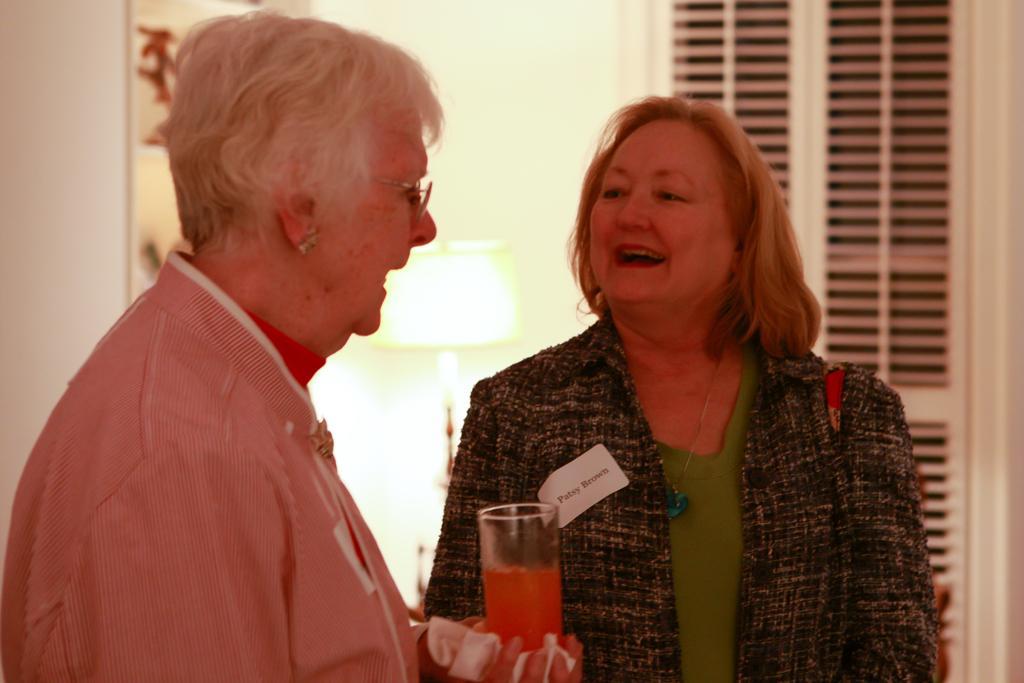Please provide a concise description of this image. In the image there are two women, the first woman is holding the glass in her hand and both the women are laughing, the background of the woman is blur. 